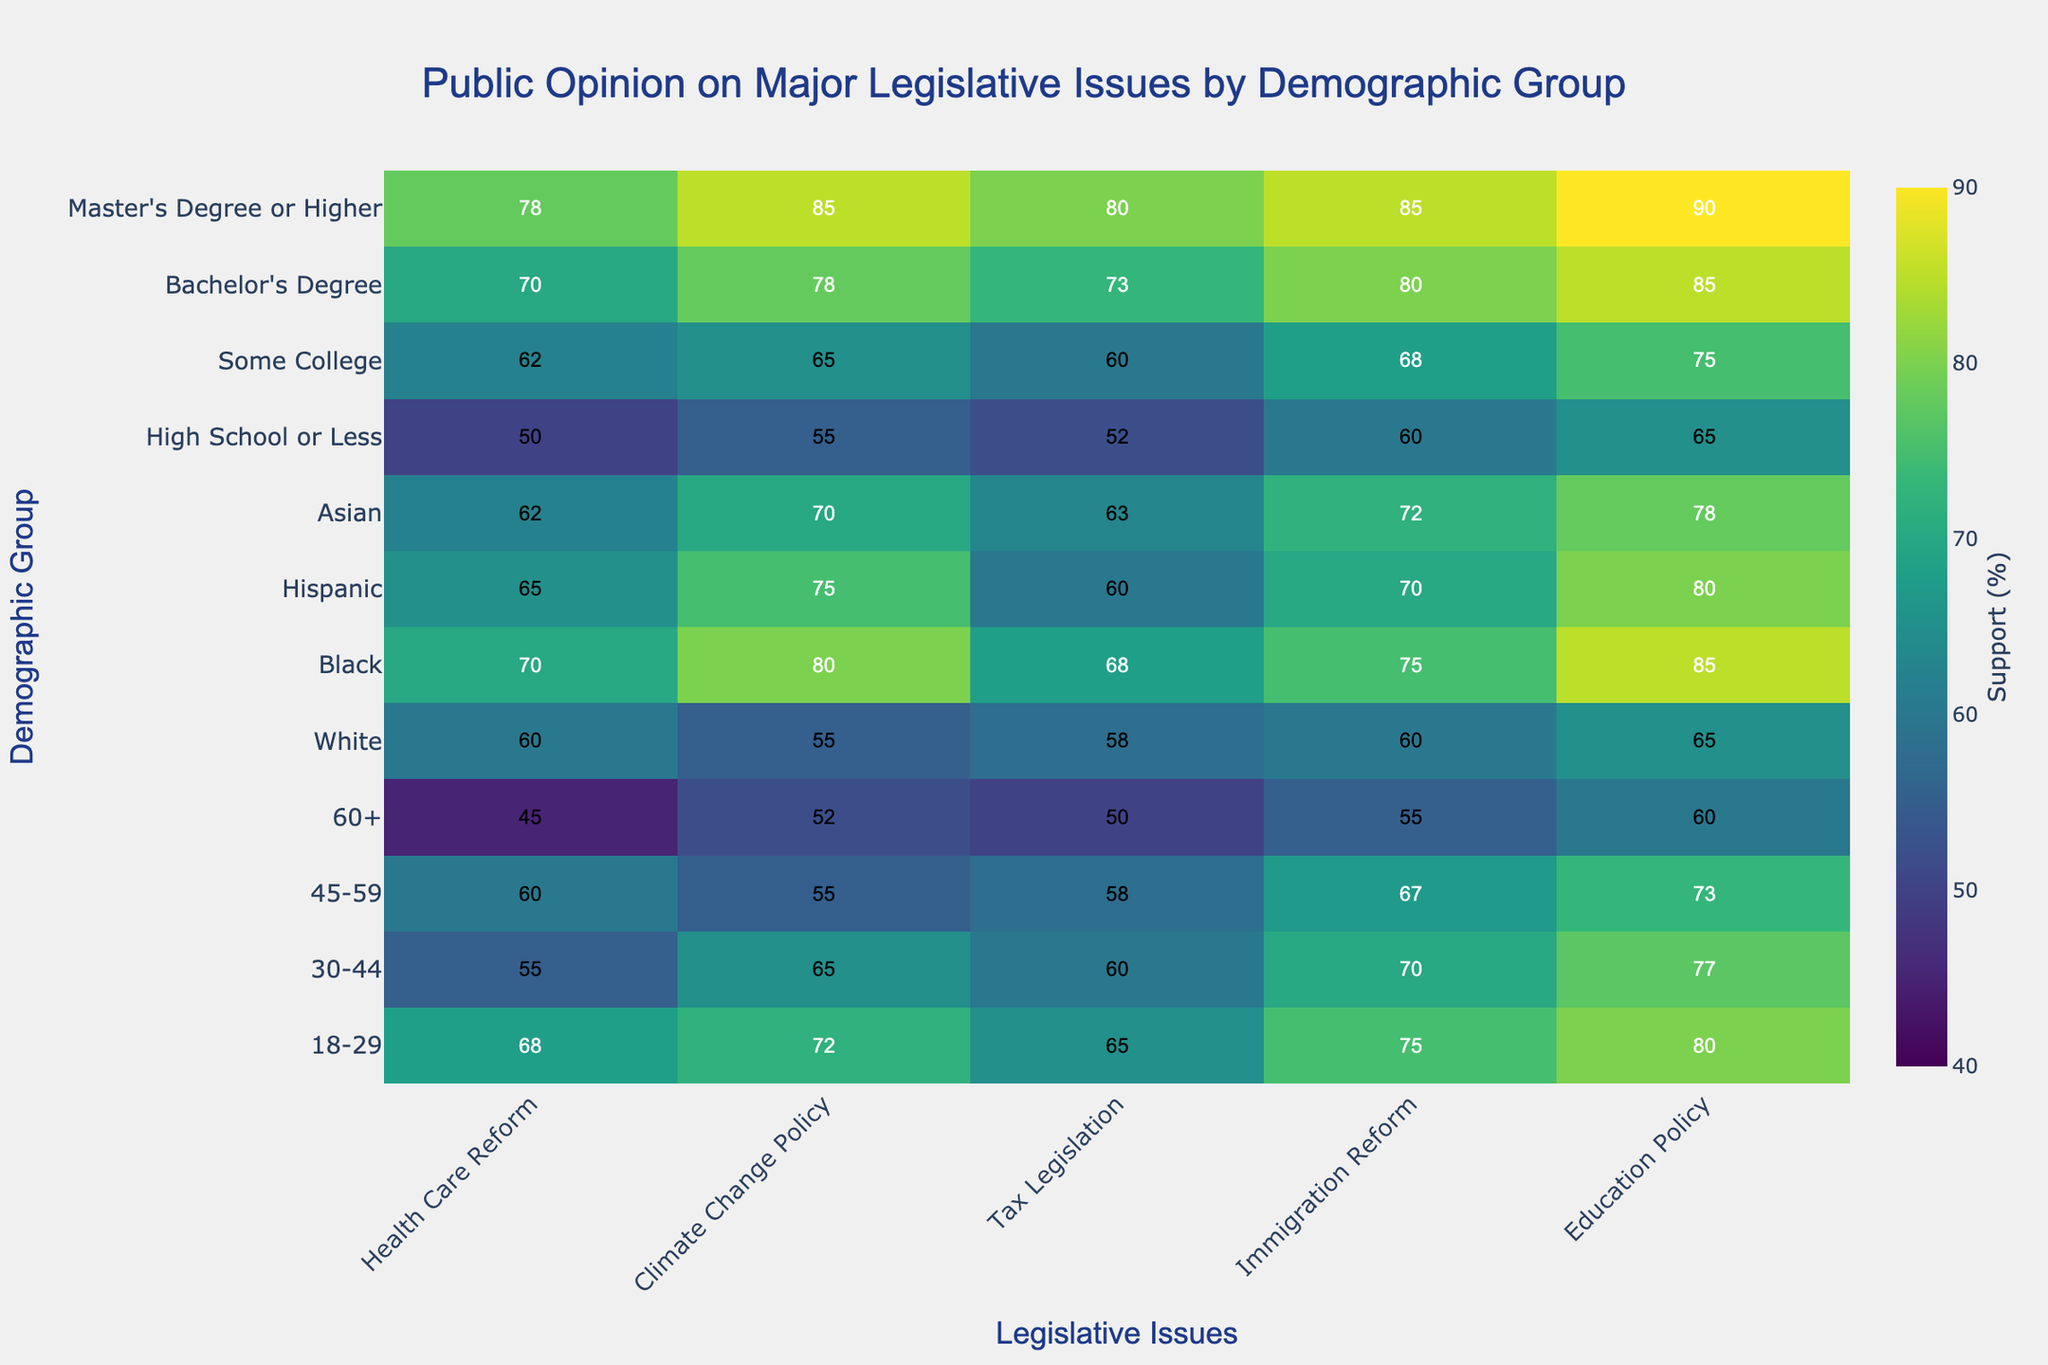what is the title of the heatmap? The title of the heatmap is prominently displayed at the top of the figure.
Answer: Public Opinion on Major Legislative Issues by Demographic Group What age group shows the highest support for immigration reform? Locate the highest value under the "Immigration Reform" column within the "Age Group" rows and read the corresponding category on the y-axis.
Answer: 18-29 How much higher is the support for climate change policy among Asian individuals compared to White individuals? Find the values for Asian and White individuals under "Climate Change Policy" and subtract the White value from the Asian value: 70 - 55 = 15
Answer: 15 Which demographic group has the lowest support for health care reform? Identify the lowest value in the "Health Care Reform" column and find the corresponding category on the y-axis or the demographic groups-wise legend.
Answer: 60+ On average, how does support for education policy change across different education levels? Calculate the average by summing the support values for "High School or Less," "Some College," "Bachelor's Degree," and "Master's Degree or Higher" and dividing by the number of data points: (65 + 75 + 85 + 90) / 4 = 78.75
Answer: 78.75 Which legislative issue has the most consistent support across all age groups? Compare the ranges (difference between highest and lowest values) for each legislative issue across age groups. The legislative issue with the smallest range is the most consistent.
Answer: Education Policy What is the support level for tax legislation among individuals with a Master's degree or higher? Look at the value associated with "Master's Degree or Higher” under the "Tax Legislation" column.
Answer: 80 Is the pattern of support for immigration reform similar between Hispanic and Black demographic groups? Compare the support values for "Immigration Reform" for both the Hispanic and Black demographic groups to see if they are close or similar.
Answer: Yes How much more support is there for health care reform among individuals aged 18-29 compared to those aged 60+? Subtract the value of the 60+ age group from the 18-29 age group for "Health Care Reform": 68 - 45 = 23
Answer: 23 